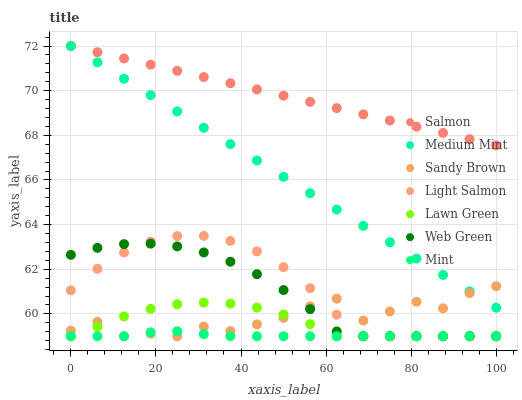Does Mint have the minimum area under the curve?
Answer yes or no. Yes. Does Salmon have the maximum area under the curve?
Answer yes or no. Yes. Does Lawn Green have the minimum area under the curve?
Answer yes or no. No. Does Lawn Green have the maximum area under the curve?
Answer yes or no. No. Is Medium Mint the smoothest?
Answer yes or no. Yes. Is Sandy Brown the roughest?
Answer yes or no. Yes. Is Lawn Green the smoothest?
Answer yes or no. No. Is Lawn Green the roughest?
Answer yes or no. No. Does Lawn Green have the lowest value?
Answer yes or no. Yes. Does Salmon have the lowest value?
Answer yes or no. No. Does Salmon have the highest value?
Answer yes or no. Yes. Does Lawn Green have the highest value?
Answer yes or no. No. Is Lawn Green less than Medium Mint?
Answer yes or no. Yes. Is Medium Mint greater than Light Salmon?
Answer yes or no. Yes. Does Mint intersect Lawn Green?
Answer yes or no. Yes. Is Mint less than Lawn Green?
Answer yes or no. No. Is Mint greater than Lawn Green?
Answer yes or no. No. Does Lawn Green intersect Medium Mint?
Answer yes or no. No. 